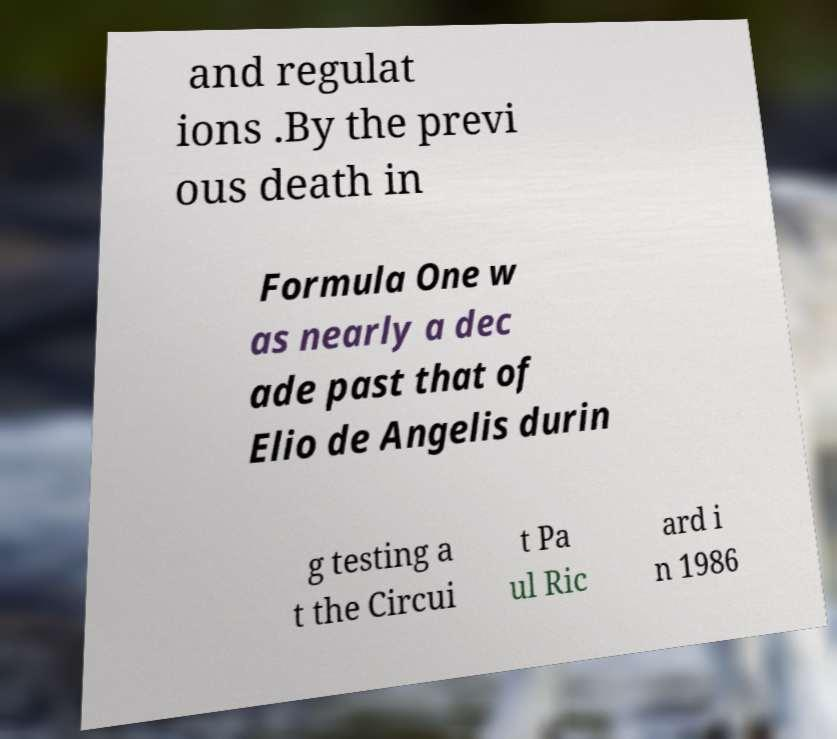What messages or text are displayed in this image? I need them in a readable, typed format. and regulat ions .By the previ ous death in Formula One w as nearly a dec ade past that of Elio de Angelis durin g testing a t the Circui t Pa ul Ric ard i n 1986 